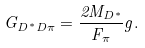<formula> <loc_0><loc_0><loc_500><loc_500>G _ { D ^ { \ast } D \pi } = \frac { 2 M _ { D ^ { \ast } } } { F _ { \pi } } g .</formula> 